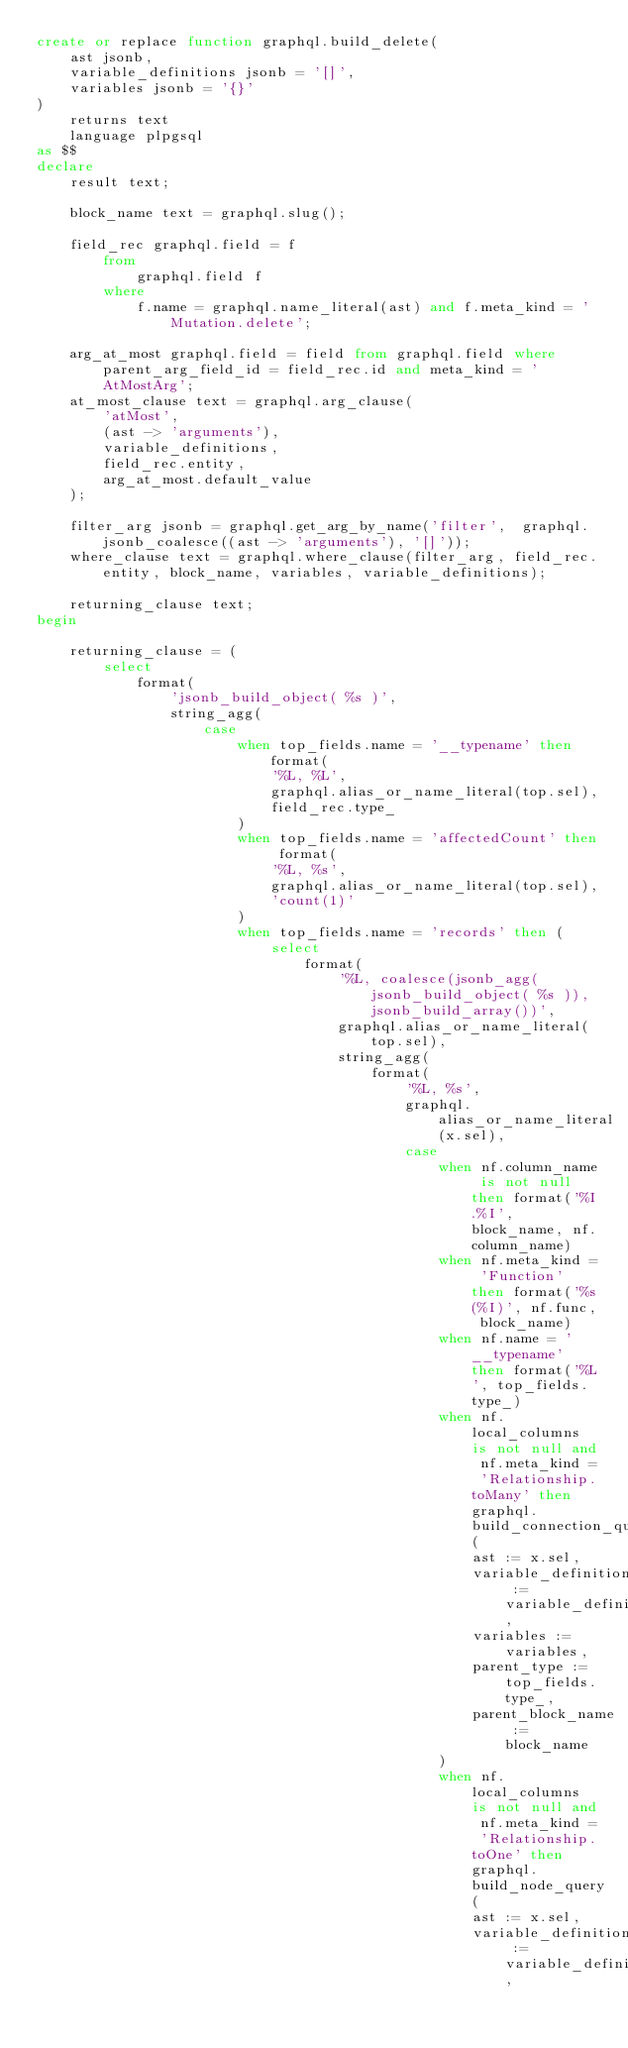Convert code to text. <code><loc_0><loc_0><loc_500><loc_500><_SQL_>create or replace function graphql.build_delete(
    ast jsonb,
    variable_definitions jsonb = '[]',
    variables jsonb = '{}'
)
    returns text
    language plpgsql
as $$
declare
    result text;

    block_name text = graphql.slug();

    field_rec graphql.field = f
        from
            graphql.field f
        where
            f.name = graphql.name_literal(ast) and f.meta_kind = 'Mutation.delete';

    arg_at_most graphql.field = field from graphql.field where parent_arg_field_id = field_rec.id and meta_kind = 'AtMostArg';
    at_most_clause text = graphql.arg_clause(
        'atMost',
        (ast -> 'arguments'),
        variable_definitions,
        field_rec.entity,
        arg_at_most.default_value
    );

    filter_arg jsonb = graphql.get_arg_by_name('filter',  graphql.jsonb_coalesce((ast -> 'arguments'), '[]'));
    where_clause text = graphql.where_clause(filter_arg, field_rec.entity, block_name, variables, variable_definitions);

    returning_clause text;
begin

    returning_clause = (
        select
            format(
                'jsonb_build_object( %s )',
                string_agg(
                    case
                        when top_fields.name = '__typename' then format(
                            '%L, %L',
                            graphql.alias_or_name_literal(top.sel),
                            field_rec.type_
                        )
                        when top_fields.name = 'affectedCount' then format(
                            '%L, %s',
                            graphql.alias_or_name_literal(top.sel),
                            'count(1)'
                        )
                        when top_fields.name = 'records' then (
                            select
                                format(
                                    '%L, coalesce(jsonb_agg(jsonb_build_object( %s )), jsonb_build_array())',
                                    graphql.alias_or_name_literal(top.sel),
                                    string_agg(
                                        format(
                                            '%L, %s',
                                            graphql.alias_or_name_literal(x.sel),
                                            case
                                                when nf.column_name is not null then format('%I.%I', block_name, nf.column_name)
                                                when nf.meta_kind = 'Function' then format('%s(%I)', nf.func, block_name)
                                                when nf.name = '__typename' then format('%L', top_fields.type_)
                                                when nf.local_columns is not null and nf.meta_kind = 'Relationship.toMany' then graphql.build_connection_query(
                                                    ast := x.sel,
                                                    variable_definitions := variable_definitions,
                                                    variables := variables,
                                                    parent_type := top_fields.type_,
                                                    parent_block_name := block_name
                                                )
                                                when nf.local_columns is not null and nf.meta_kind = 'Relationship.toOne' then graphql.build_node_query(
                                                    ast := x.sel,
                                                    variable_definitions := variable_definitions,</code> 